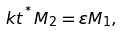<formula> <loc_0><loc_0><loc_500><loc_500>k t ^ { ^ { * } } M _ { 2 } = \varepsilon M _ { 1 } ,</formula> 